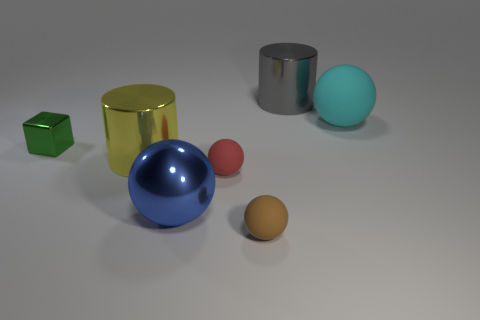Add 3 large cyan balls. How many objects exist? 10 Subtract all small red balls. How many balls are left? 3 Subtract 1 balls. How many balls are left? 3 Add 5 green objects. How many green objects are left? 6 Add 5 big gray metal spheres. How many big gray metal spheres exist? 5 Subtract all gray cylinders. How many cylinders are left? 1 Subtract 0 cyan cubes. How many objects are left? 7 Subtract all balls. How many objects are left? 3 Subtract all yellow cylinders. Subtract all brown cubes. How many cylinders are left? 1 Subtract all cyan cylinders. How many red blocks are left? 0 